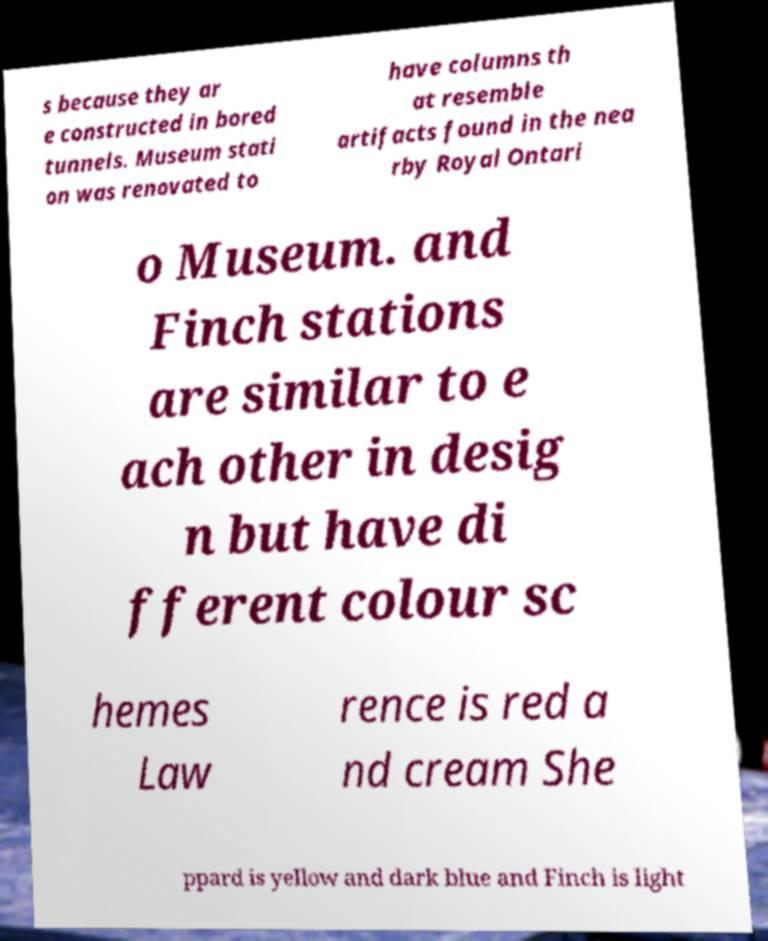For documentation purposes, I need the text within this image transcribed. Could you provide that? s because they ar e constructed in bored tunnels. Museum stati on was renovated to have columns th at resemble artifacts found in the nea rby Royal Ontari o Museum. and Finch stations are similar to e ach other in desig n but have di fferent colour sc hemes Law rence is red a nd cream She ppard is yellow and dark blue and Finch is light 